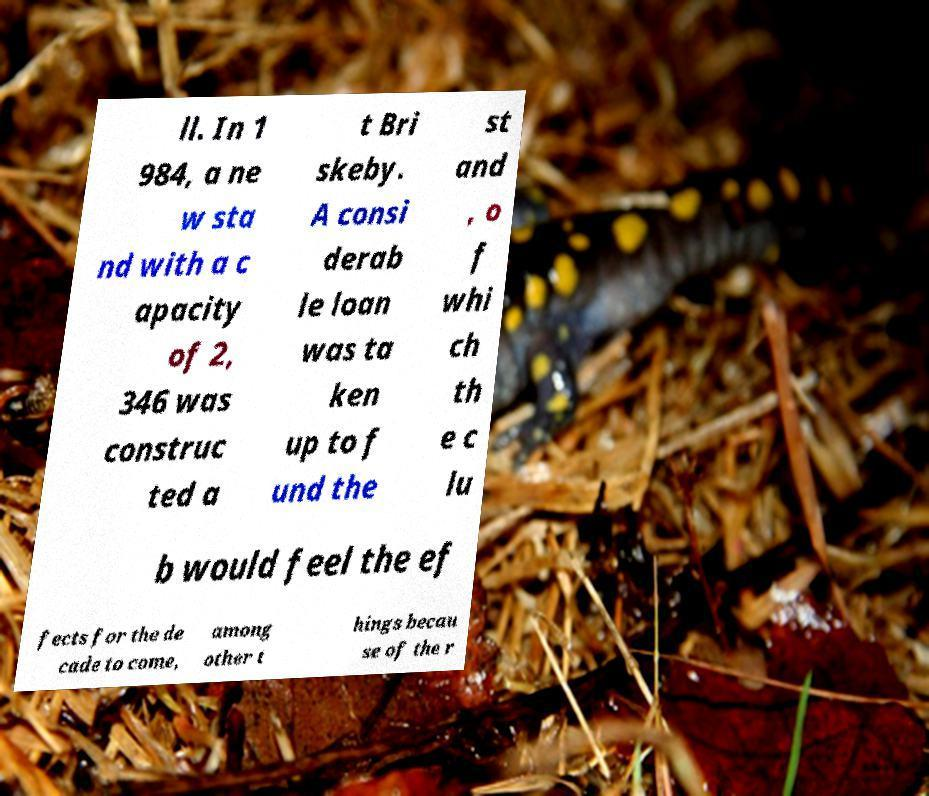Please identify and transcribe the text found in this image. ll. In 1 984, a ne w sta nd with a c apacity of 2, 346 was construc ted a t Bri skeby. A consi derab le loan was ta ken up to f und the st and , o f whi ch th e c lu b would feel the ef fects for the de cade to come, among other t hings becau se of the r 